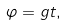Convert formula to latex. <formula><loc_0><loc_0><loc_500><loc_500>\varphi = g t ,</formula> 